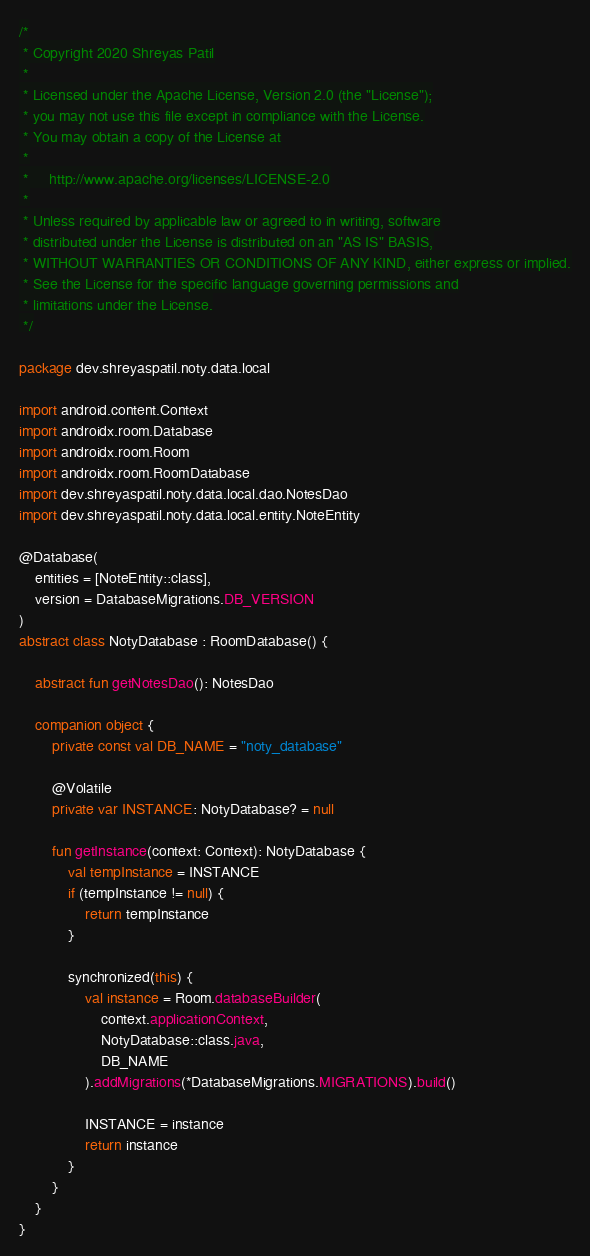<code> <loc_0><loc_0><loc_500><loc_500><_Kotlin_>/*
 * Copyright 2020 Shreyas Patil
 *
 * Licensed under the Apache License, Version 2.0 (the "License");
 * you may not use this file except in compliance with the License.
 * You may obtain a copy of the License at
 *
 *     http://www.apache.org/licenses/LICENSE-2.0
 *
 * Unless required by applicable law or agreed to in writing, software
 * distributed under the License is distributed on an "AS IS" BASIS,
 * WITHOUT WARRANTIES OR CONDITIONS OF ANY KIND, either express or implied.
 * See the License for the specific language governing permissions and
 * limitations under the License.
 */

package dev.shreyaspatil.noty.data.local

import android.content.Context
import androidx.room.Database
import androidx.room.Room
import androidx.room.RoomDatabase
import dev.shreyaspatil.noty.data.local.dao.NotesDao
import dev.shreyaspatil.noty.data.local.entity.NoteEntity

@Database(
    entities = [NoteEntity::class],
    version = DatabaseMigrations.DB_VERSION
)
abstract class NotyDatabase : RoomDatabase() {

    abstract fun getNotesDao(): NotesDao

    companion object {
        private const val DB_NAME = "noty_database"

        @Volatile
        private var INSTANCE: NotyDatabase? = null

        fun getInstance(context: Context): NotyDatabase {
            val tempInstance = INSTANCE
            if (tempInstance != null) {
                return tempInstance
            }

            synchronized(this) {
                val instance = Room.databaseBuilder(
                    context.applicationContext,
                    NotyDatabase::class.java,
                    DB_NAME
                ).addMigrations(*DatabaseMigrations.MIGRATIONS).build()

                INSTANCE = instance
                return instance
            }
        }
    }
}
</code> 